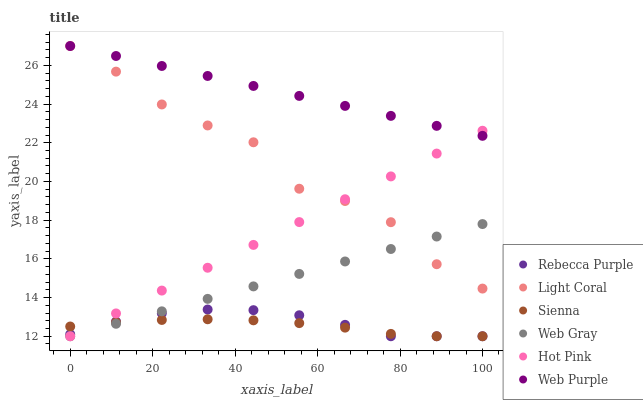Does Sienna have the minimum area under the curve?
Answer yes or no. Yes. Does Web Purple have the maximum area under the curve?
Answer yes or no. Yes. Does Web Gray have the minimum area under the curve?
Answer yes or no. No. Does Web Gray have the maximum area under the curve?
Answer yes or no. No. Is Web Purple the smoothest?
Answer yes or no. Yes. Is Light Coral the roughest?
Answer yes or no. Yes. Is Web Gray the smoothest?
Answer yes or no. No. Is Web Gray the roughest?
Answer yes or no. No. Does Sienna have the lowest value?
Answer yes or no. Yes. Does Light Coral have the lowest value?
Answer yes or no. No. Does Web Purple have the highest value?
Answer yes or no. Yes. Does Web Gray have the highest value?
Answer yes or no. No. Is Web Gray less than Web Purple?
Answer yes or no. Yes. Is Light Coral greater than Rebecca Purple?
Answer yes or no. Yes. Does Web Gray intersect Sienna?
Answer yes or no. Yes. Is Web Gray less than Sienna?
Answer yes or no. No. Is Web Gray greater than Sienna?
Answer yes or no. No. Does Web Gray intersect Web Purple?
Answer yes or no. No. 